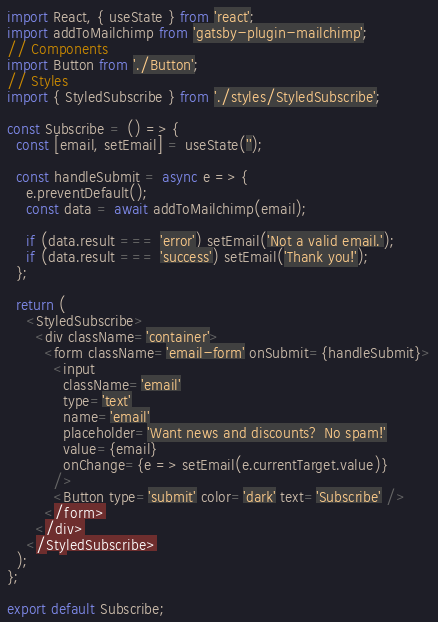Convert code to text. <code><loc_0><loc_0><loc_500><loc_500><_JavaScript_>import React, { useState } from 'react';
import addToMailchimp from 'gatsby-plugin-mailchimp';
// Components
import Button from './Button';
// Styles
import { StyledSubscribe } from './styles/StyledSubscribe';

const Subscribe = () => {
  const [email, setEmail] = useState('');

  const handleSubmit = async e => {
    e.preventDefault();
    const data = await addToMailchimp(email);

    if (data.result === 'error') setEmail('Not a valid email.');
    if (data.result === 'success') setEmail('Thank you!');
  };

  return (
    <StyledSubscribe>
      <div className='container'>
        <form className='email-form' onSubmit={handleSubmit}>
          <input
            className='email'
            type='text'
            name='email'
            placeholder='Want news and discounts? No spam!'
            value={email}
            onChange={e => setEmail(e.currentTarget.value)}
          />
          <Button type='submit' color='dark' text='Subscribe' />
        </form>
      </div>
    </StyledSubscribe>
  );
};

export default Subscribe;
</code> 